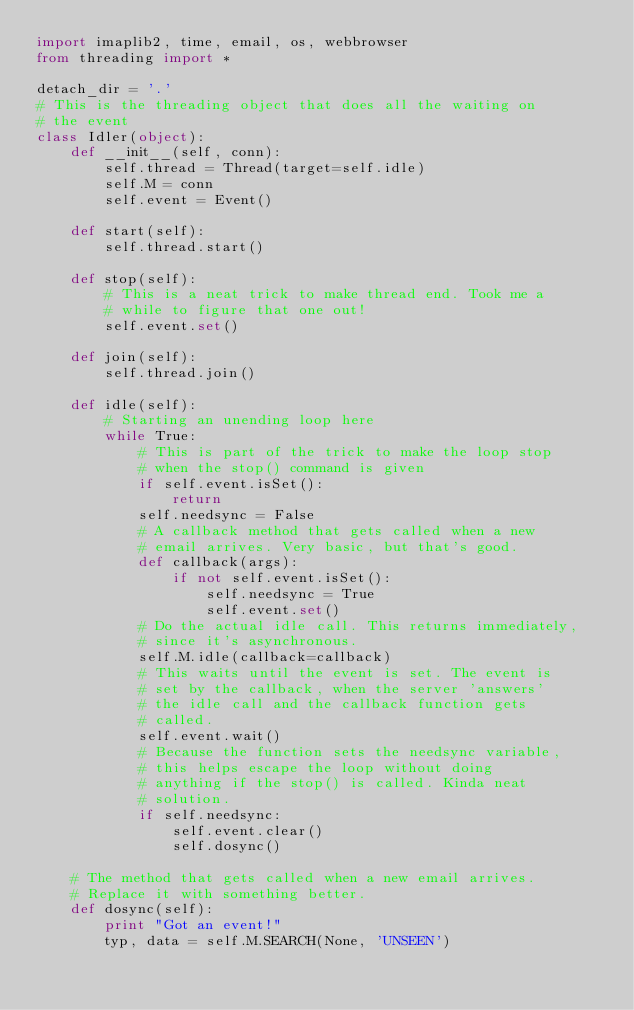<code> <loc_0><loc_0><loc_500><loc_500><_Python_>import imaplib2, time, email, os, webbrowser
from threading import *

detach_dir = '.'
# This is the threading object that does all the waiting on 
# the event
class Idler(object):
    def __init__(self, conn):
        self.thread = Thread(target=self.idle)
        self.M = conn
        self.event = Event()
 
    def start(self):
        self.thread.start()
 
    def stop(self):
        # This is a neat trick to make thread end. Took me a 
        # while to figure that one out!
        self.event.set()
 
    def join(self):
        self.thread.join()
 
    def idle(self):
        # Starting an unending loop here
        while True:
            # This is part of the trick to make the loop stop 
            # when the stop() command is given
            if self.event.isSet():
                return
            self.needsync = False
            # A callback method that gets called when a new 
            # email arrives. Very basic, but that's good.
            def callback(args):
                if not self.event.isSet():
                    self.needsync = True
                    self.event.set()
            # Do the actual idle call. This returns immediately, 
            # since it's asynchronous.
            self.M.idle(callback=callback)
            # This waits until the event is set. The event is 
            # set by the callback, when the server 'answers' 
            # the idle call and the callback function gets 
            # called.
            self.event.wait()
            # Because the function sets the needsync variable,
            # this helps escape the loop without doing 
            # anything if the stop() is called. Kinda neat 
            # solution.
            if self.needsync:
                self.event.clear()
                self.dosync()
 
    # The method that gets called when a new email arrives. 
    # Replace it with something better.
    def dosync(self):
        print "Got an event!"
        typ, data = self.M.SEARCH(None, 'UNSEEN')
        </code> 